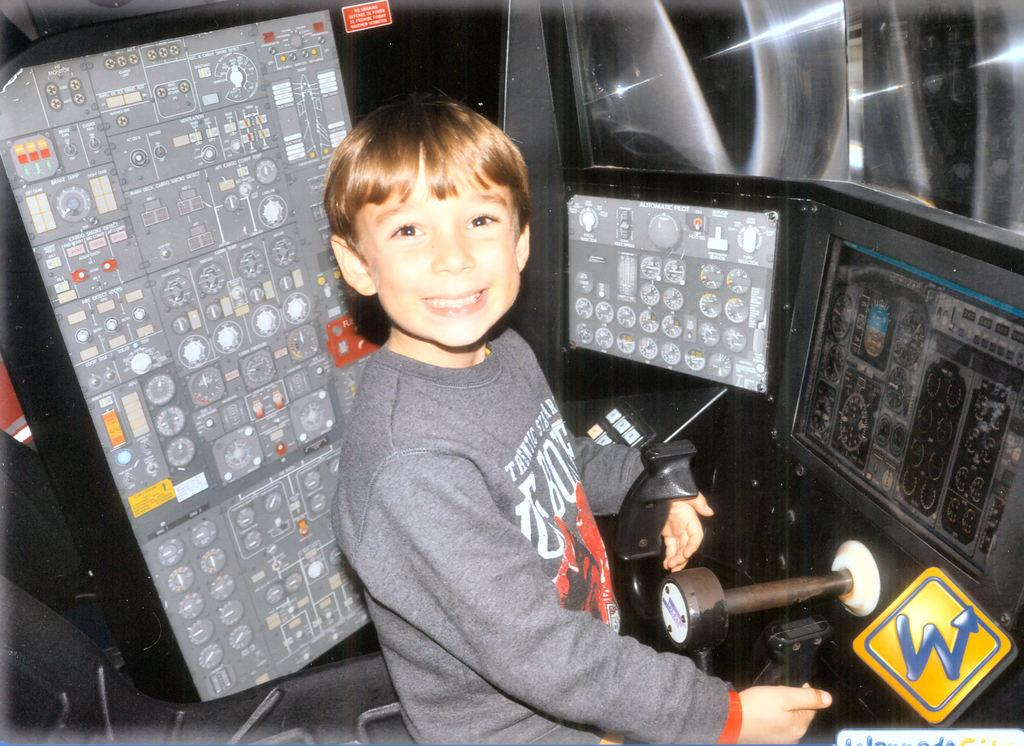<image>
Offer a succinct explanation of the picture presented. a boy in a vehicle with the letter w next to him 